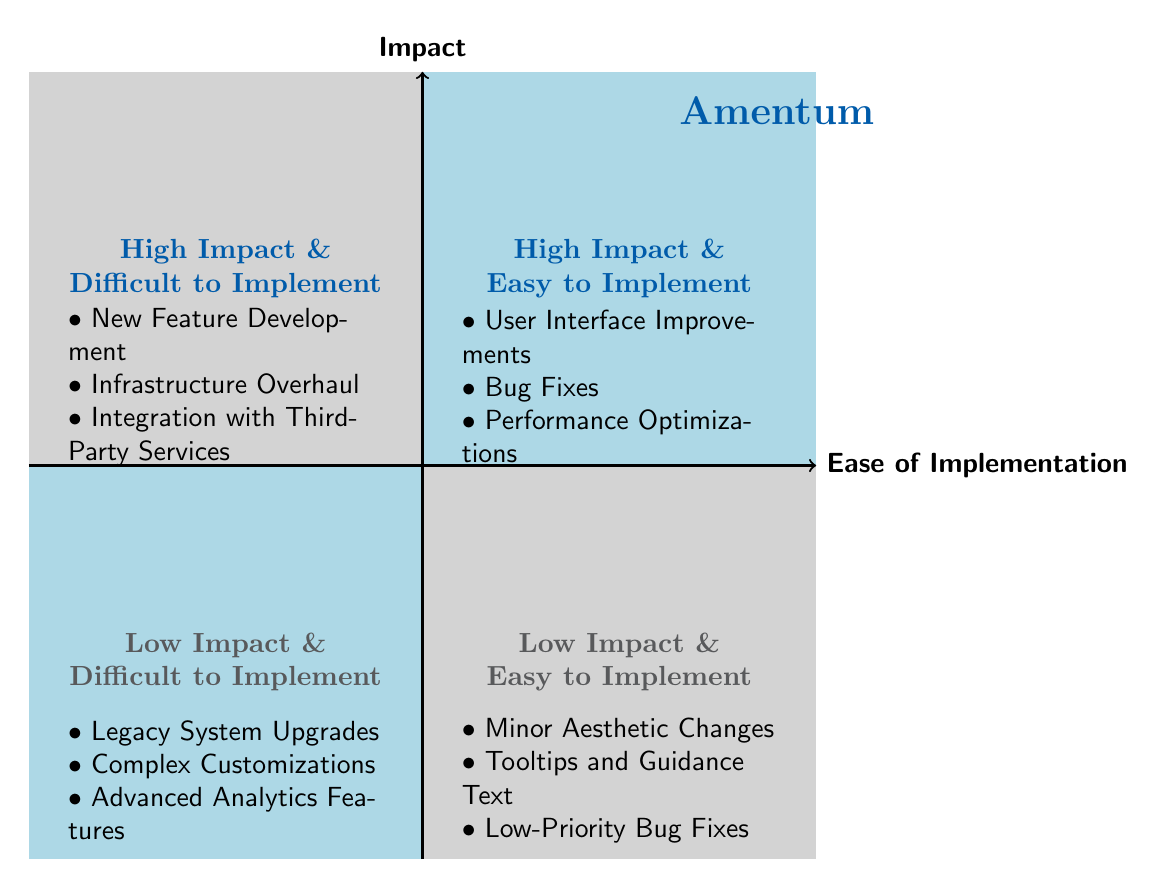What's listed in the "High Impact & Easy to Implement" quadrant? In the diagram, this quadrant contains three items: User Interface Improvements, Bug Fixes, and Performance Optimizations.
Answer: User Interface Improvements, Bug Fixes, Performance Optimizations How many items are in the "Low Impact & Difficult to Implement" quadrant? The diagram shows that this quadrant contains three items: Legacy System Upgrades, Complex Customizations, and Advanced Analytics Features. Therefore, there are three items in total.
Answer: 3 Which quadrant contains "New Feature Development"? According to the diagram, "New Feature Development" is located in the "High Impact & Difficult to Implement" quadrant.
Answer: High Impact & Difficult to Implement What is the relationship between "Bug Fixes" and "Performance Optimizations"? Both "Bug Fixes" and "Performance Optimizations" are located in the "High Impact & Easy to Implement" quadrant, indicating they are similarly categorized in terms of impact and ease of implementation.
Answer: Same quadrant Which has a higher impact: "Legacy System Upgrades" or "Minor Aesthetic Changes"? "Legacy System Upgrades" is in the "Low Impact & Difficult to Implement" quadrant, while "Minor Aesthetic Changes" is in the "Low Impact & Easy to Implement" quadrant. Both are categorized as low impact, but Legacy System Upgrades is more challenging to implement.
Answer: Same low impact Identify one item that is easy to implement and provides high impact. The item that fits this description is found in the "High Impact & Easy to Implement" quadrant; one example is "User Interface Improvements."
Answer: User Interface Improvements Which quadrant has no items listed? The diagram clearly indicates that there are no items in the "High Impact & Difficult to Implement" quadrant.
Answer: None What is a commonality between "Tooltips and Guidance Text" and "Minor Aesthetic Changes"? Both items are located in the "Low Impact & Easy to Implement" quadrant, indicating they have similar properties in terms of impact and ease of implementation.
Answer: Same quadrant How many total quadrants are represented in the diagram? The diagram comprises four quadrants, which categorize different items based on their impact and ease of implementation: High Impact & Difficult, High Impact & Easy, Low Impact & Difficult, and Low Impact & Easy.
Answer: 4 